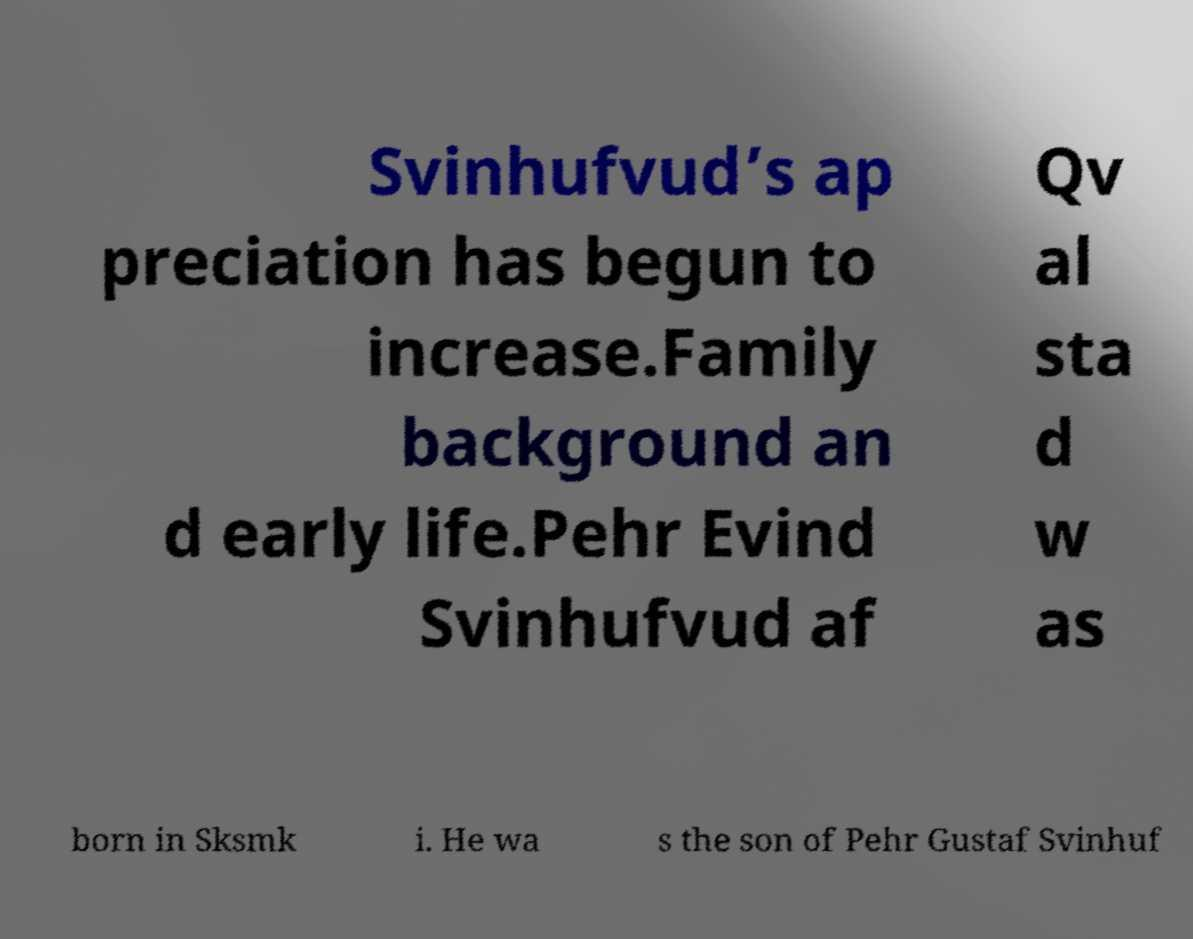There's text embedded in this image that I need extracted. Can you transcribe it verbatim? Svinhufvud’s ap preciation has begun to increase.Family background an d early life.Pehr Evind Svinhufvud af Qv al sta d w as born in Sksmk i. He wa s the son of Pehr Gustaf Svinhuf 